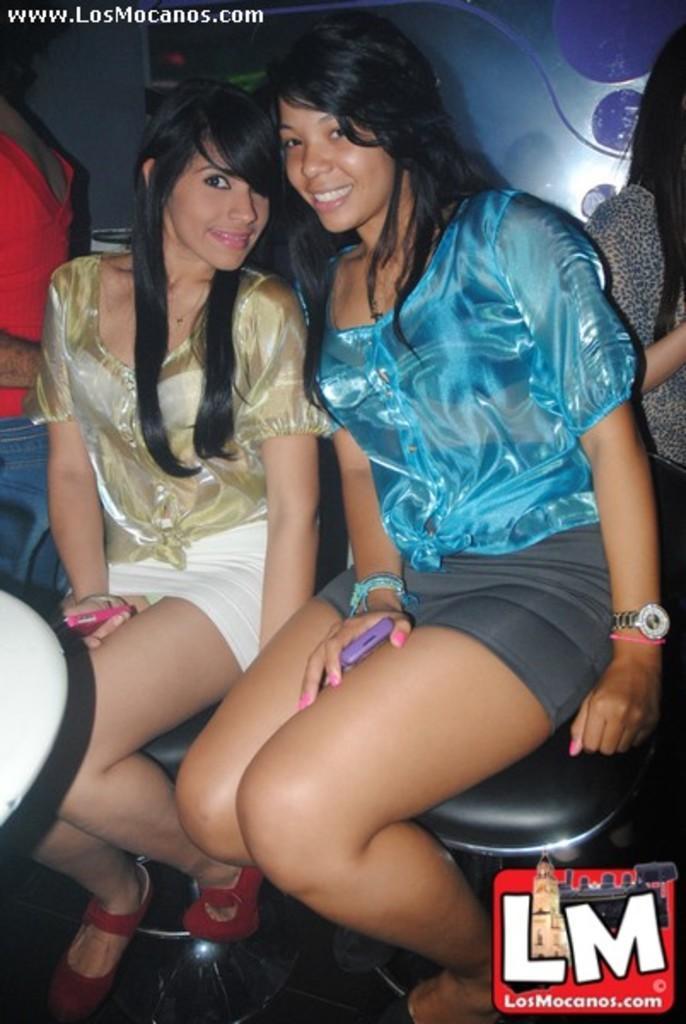Can you describe this image briefly? In this picture we can see two women sitting on a platform,they are smiling and in the background we can see people. 